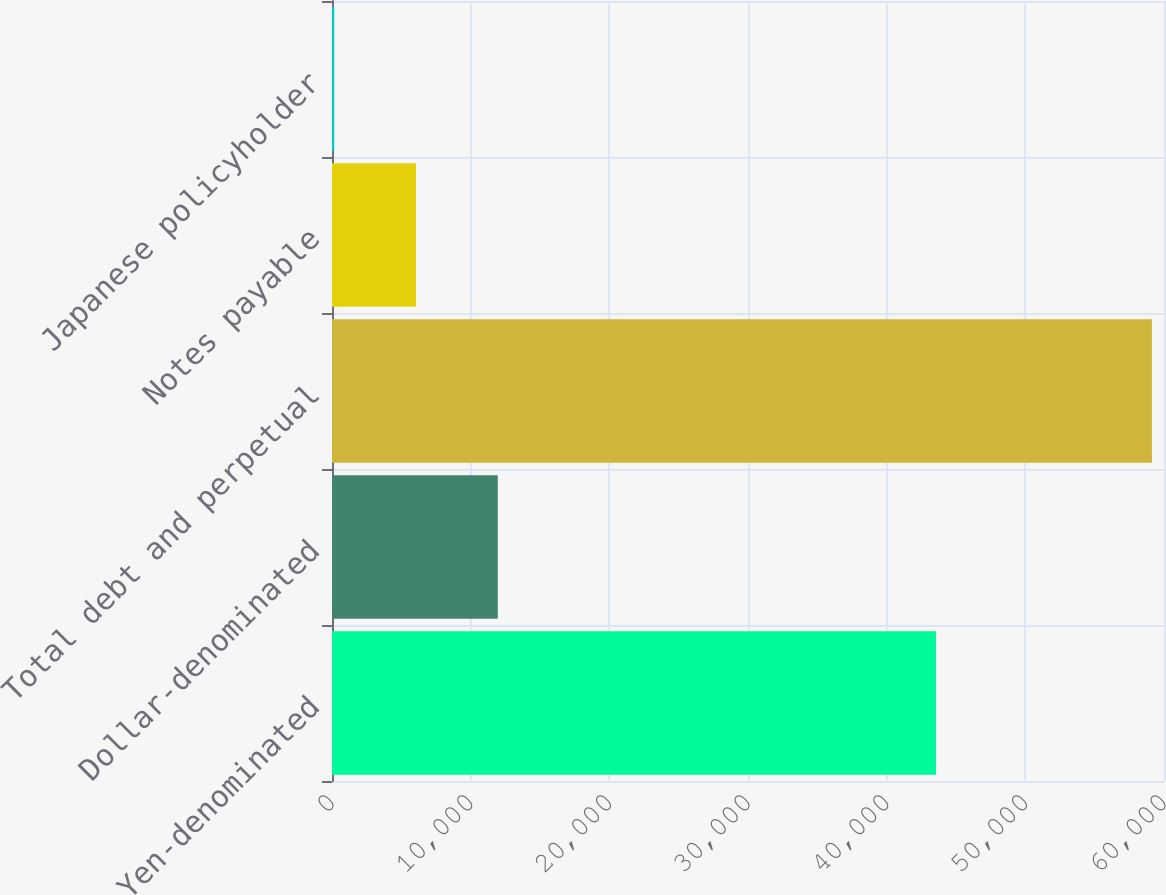<chart> <loc_0><loc_0><loc_500><loc_500><bar_chart><fcel>Yen-denominated<fcel>Dollar-denominated<fcel>Total debt and perpetual<fcel>Notes payable<fcel>Japanese policyholder<nl><fcel>43556<fcel>11954.8<fcel>59130<fcel>6057.9<fcel>161<nl></chart> 